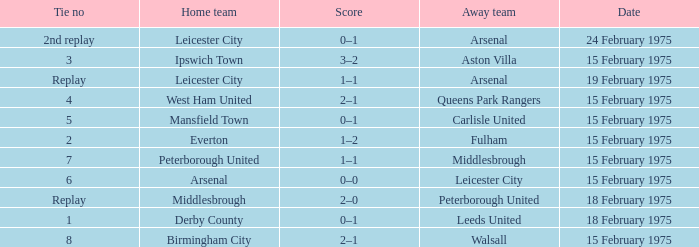Parse the full table. {'header': ['Tie no', 'Home team', 'Score', 'Away team', 'Date'], 'rows': [['2nd replay', 'Leicester City', '0–1', 'Arsenal', '24 February 1975'], ['3', 'Ipswich Town', '3–2', 'Aston Villa', '15 February 1975'], ['Replay', 'Leicester City', '1–1', 'Arsenal', '19 February 1975'], ['4', 'West Ham United', '2–1', 'Queens Park Rangers', '15 February 1975'], ['5', 'Mansfield Town', '0–1', 'Carlisle United', '15 February 1975'], ['2', 'Everton', '1–2', 'Fulham', '15 February 1975'], ['7', 'Peterborough United', '1–1', 'Middlesbrough', '15 February 1975'], ['6', 'Arsenal', '0–0', 'Leicester City', '15 February 1975'], ['Replay', 'Middlesbrough', '2–0', 'Peterborough United', '18 February 1975'], ['1', 'Derby County', '0–1', 'Leeds United', '18 February 1975'], ['8', 'Birmingham City', '2–1', 'Walsall', '15 February 1975']]} What was the date when the away team was the leeds united? 18 February 1975. 